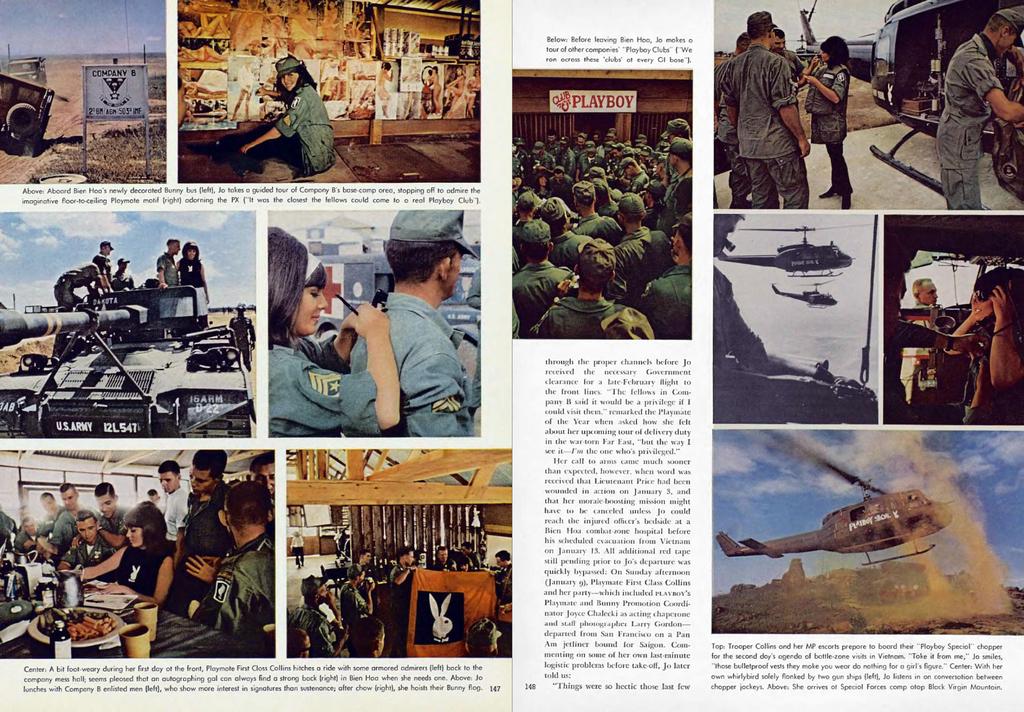What famous magazine is shown advertised here?
Offer a terse response. Playboy. 